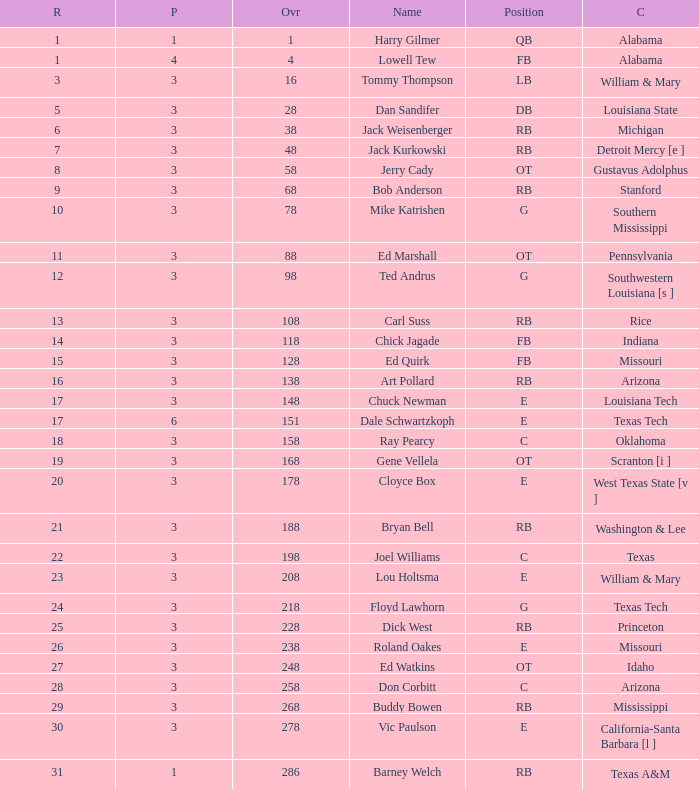Which pick has a Round smaller than 8, and an Overall smaller than 16, and a Name of harry gilmer? 1.0. 